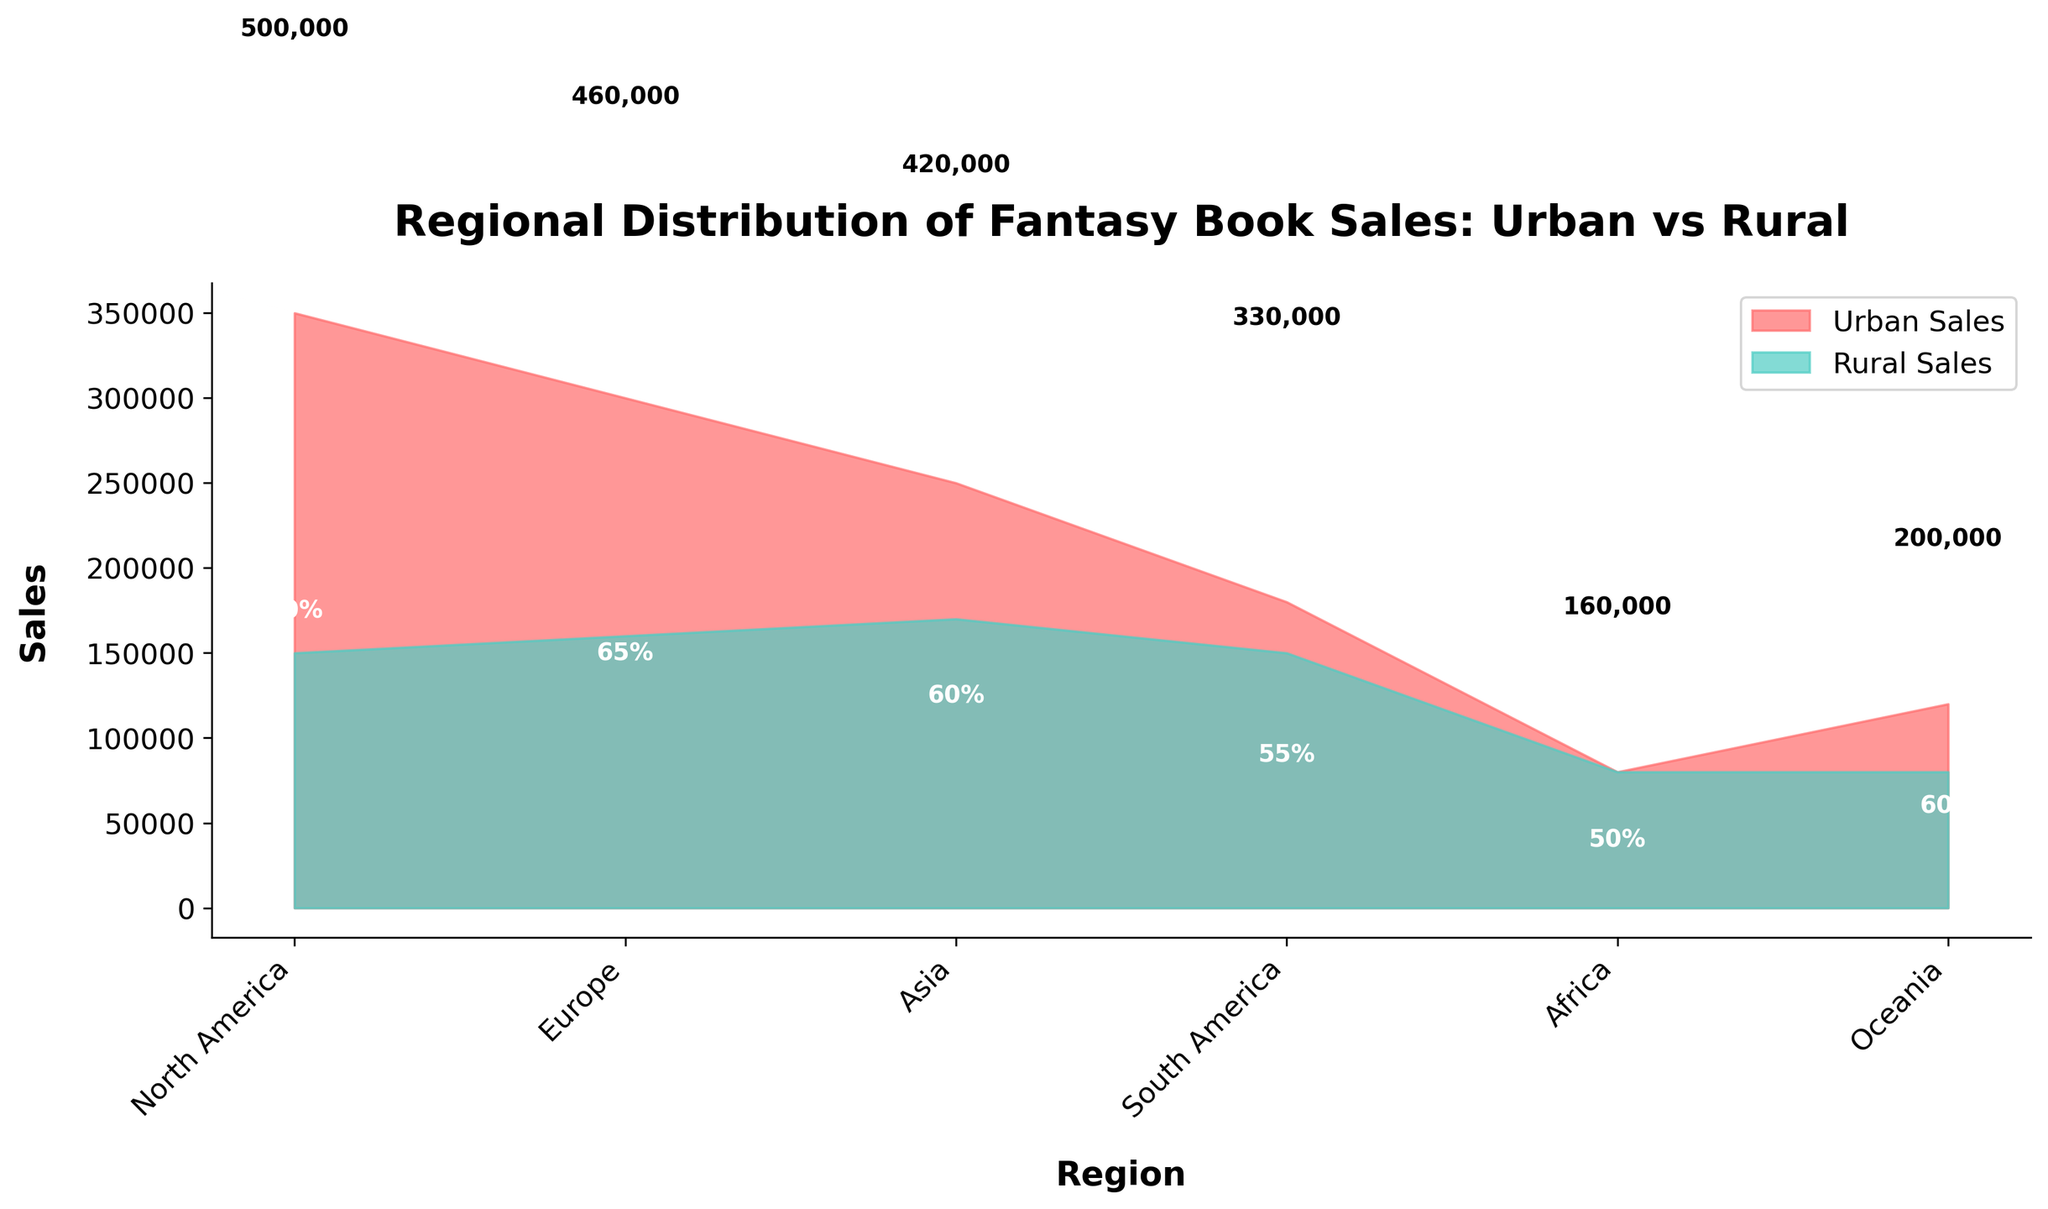What's the title of the chart? The title of the chart is usually displayed at the top in a larger, bold font. It helps to understand what the chart is about.
Answer: Regional Distribution of Fantasy Book Sales: Urban vs Rural How many regions are represented in the chart? The number of regions can be determined by counting the labeled ticks on the x-axis. There are six labels indicating the regions.
Answer: Six Which region has the highest urban sales? To answer this, compare the heights of the filled area representing urban sales for each region. The tallest urban area corresponds to the highest sales.
Answer: North America What is the total sales for Oceania? Total sales are shown by summing urban and rural sales for Oceania. Urban sales are 120,000 and rural sales are 80,000.
Answer: 200,000 Which region has an equal distribution of urban and rural sales? The chart shows equal distribution where the colored areas of urban and rural sales are at the same level, making Africa's areas equal.
Answer: Africa What is the urban percentage for Europe? The urban percentage for each region is displayed within the urban area. Look for the percentage in the region marked "Europe."
Answer: 65% How does the urban sales in Asia compare to rural sales in Asia? Compare the heights of the filled areas for urban and rural sales in Asia to see which one is higher. Urban sales are higher than rural sales in Asia.
Answer: Urban sales are higher What region has the lowest total sales? Compare the heights of the combined areas (urban + rural) for each region. The shortest combined area indicates the lowest total sales.
Answer: Africa What are the urban and rural sales totals for North America? Add the urban (350,000) and rural (150,000) sales numbers for North America. Urban sales are 350,000 and rural sales are 150,000.
Answer: Urban: 350,000, Rural: 150,000 Which region has the highest rural sales? Compare the heights of the filled areas representing rural sales for each region. The tallest rural area corresponds to the highest sales.
Answer: Asia 